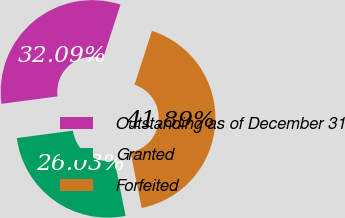<chart> <loc_0><loc_0><loc_500><loc_500><pie_chart><fcel>Outstanding as of December 31<fcel>Granted<fcel>Forfeited<nl><fcel>32.09%<fcel>26.03%<fcel>41.89%<nl></chart> 